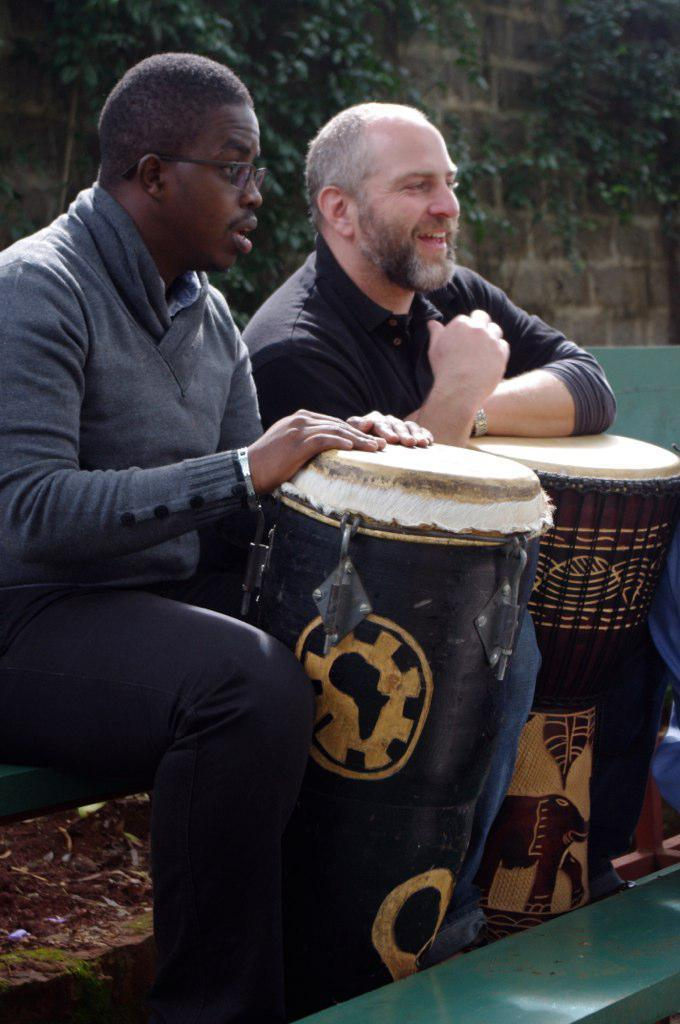How many people are in the image? There are two men in the image. What are the men doing in the image? The men are in front of two drums. What is behind the men in the image? There is a wall behind the men. What decorations are on the wall? There are branches of trees on the wall. Is there a beggar asking for money in the image? No, there is no beggar present in the image. Can you see a woman playing the drums with the men? No, there are only two men visible in the image, and they are both playing drums. 